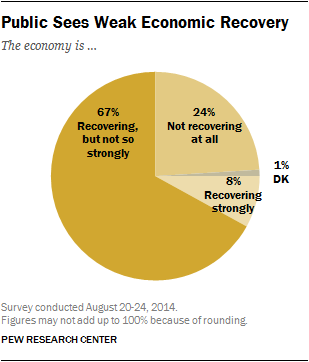Give some essential details in this illustration. The color of the largest segment is yellow. The ratio of the second and third smallest segments is approximately 0.04375. 